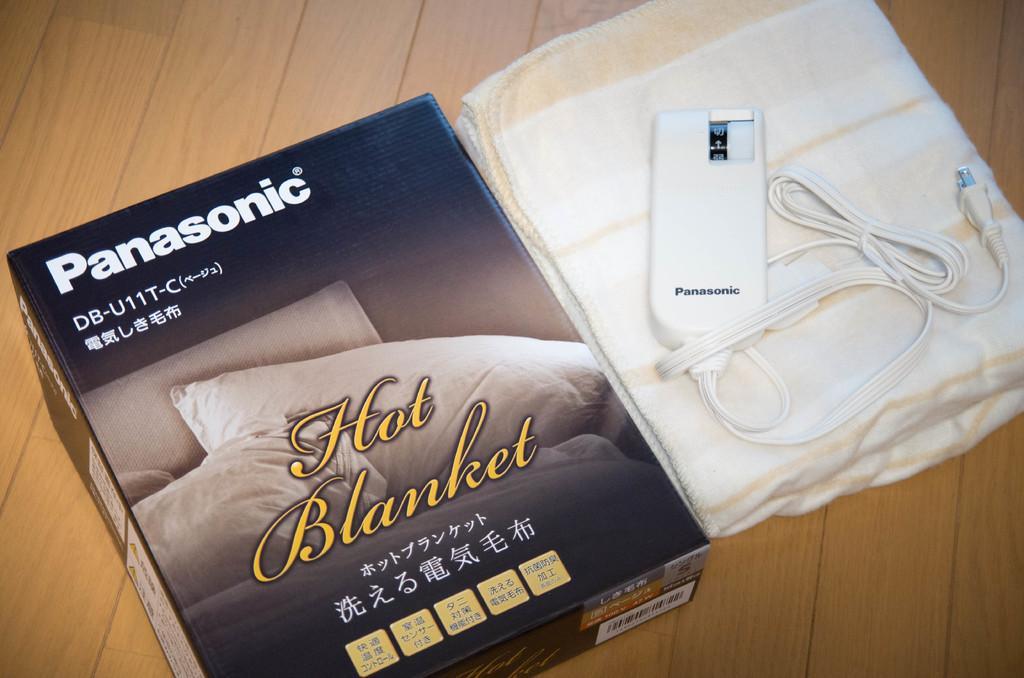Could you give a brief overview of what you see in this image? In this image in front there is a box. Beside the box there is a blanket. On top of it there is an electronic equipment which was placed on the table. 